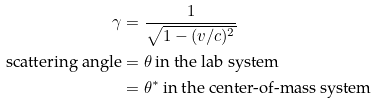Convert formula to latex. <formula><loc_0><loc_0><loc_500><loc_500>\gamma & = \frac { 1 } { \sqrt { 1 - ( v / c ) ^ { 2 } } } \\ \text {scattering angle} & = \theta \, \text {in the lab system} \\ & = \theta ^ { * } \, \text {in the center-of-mass system}</formula> 